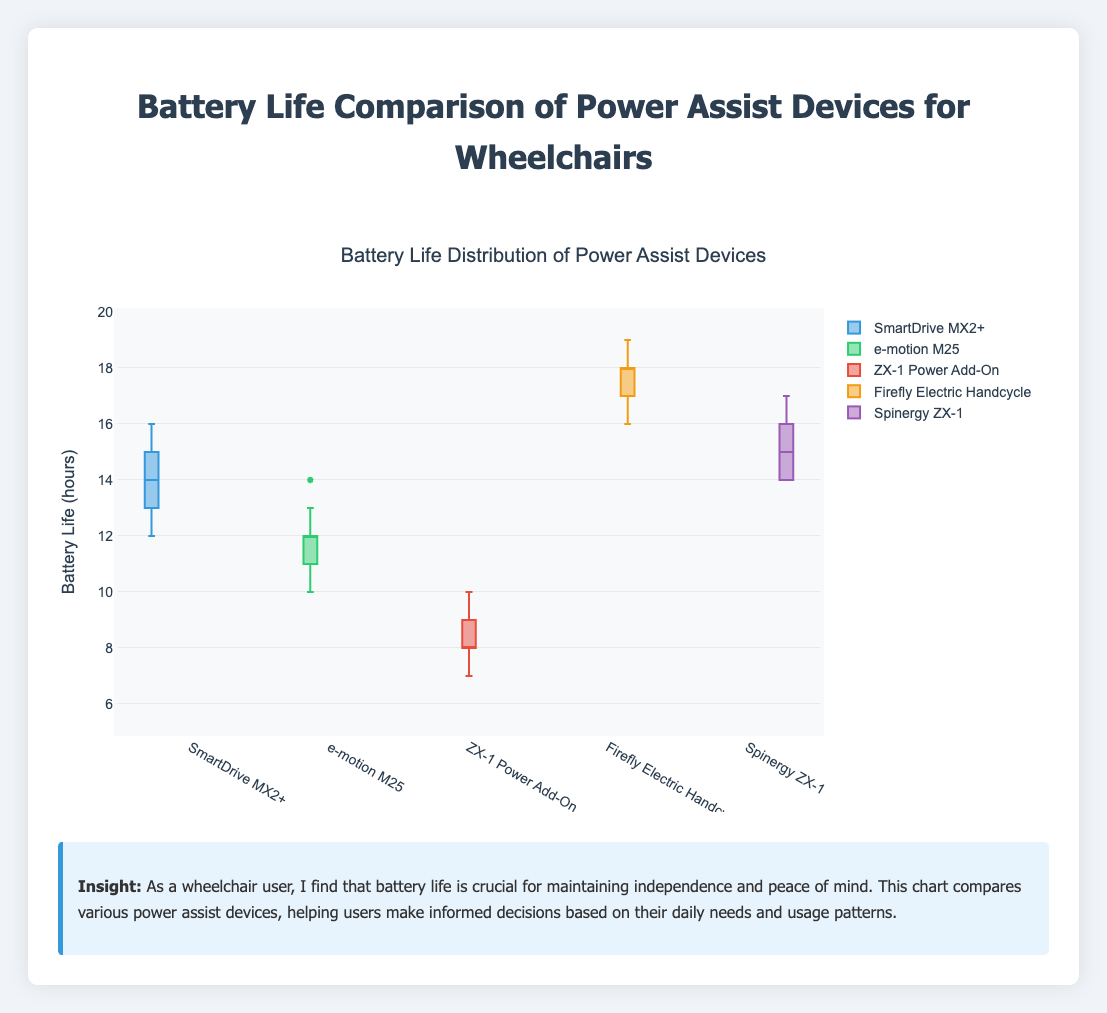What is the median battery life of the SmartDrive MX2+? To find the median battery life, locate the middle value once all values are ordered from smallest to largest. For SmartDrive MX2+, the ordered battery life hours are [12, 13, 13, 14, 14, 14, 14, 15, 15, 16]. The median lies between the 5th and 6th values (both 14), thus the median is 14.
Answer: 14 Which device has the highest median battery life? Look at the central line within each box plot, which represents the median. The device with the highest central line is the Firefly Electric Handcycle.
Answer: Firefly Electric Handcycle What is the interquartile range (IQR) for the ZX-1 Power Add-On? The IQR is the difference between the third quartile (Q3) and the first quartile (Q1). For ZX-1 Power Add-On, Q3 is 9, and Q1 is 8. Calculating the difference, Q3 - Q1 = 9 - 8 = 1.
Answer: 1 Compare the range of battery lives between the SmartDrive MX2+ and the e-motion M25. Which has a wider range? The range is the difference between the maximum and minimum values. For SmartDrive MX2+, the range is 16 - 12 = 4; for e-motion M25, the range is 14 - 10 = 4. Both ranges are the same.
Answer: Both have the same range What's the overall highest battery life recorded among all devices? Identify the maximum value observed in all the boxes. The highest value recorded is for the Firefly Electric Handcycle at 19 hours.
Answer: 19 hours Which device shows the most variability in battery life? The device with the widest spread in its box plot shows the most variability. The ZX-1 Power Add-On box plot spans from 7 to 10, indicating more variability compared to other devices.
Answer: ZX-1 Power Add-On How does the third quartile of Spinergy ZX-1 compare with the median of the Firefly Electric Handcycle? The third quartile (Q3) of Spinergy ZX-1 is at 16, while the median of the Firefly Electric Handcycle is at 18. Therefore, the Firefly's median is higher.
Answer: Firefly's median is higher Between the SmartDrive MX2+ and Spinergy ZX-1, which one has a higher lowest battery life recorded? Compare the minima of the two devices. SmartDrive MX2+ has a minimum of 12, whereas Spinergy ZX-1 has a minimum of 14. Spinergy ZX-1 has a higher lowest battery life.
Answer: Spinergy ZX-1 Which device has the smallest interquartile range? The smallest IQR suggests the least deviation among middle 50% of values. Firefly Electric Handcycle has the smallest IQR.
Answer: Firefly Electric Handcycle What is the median battery life of the device with the lowest median? Identify the device with the lowest median (e-motion M25). The median here is 12.
Answer: 12 